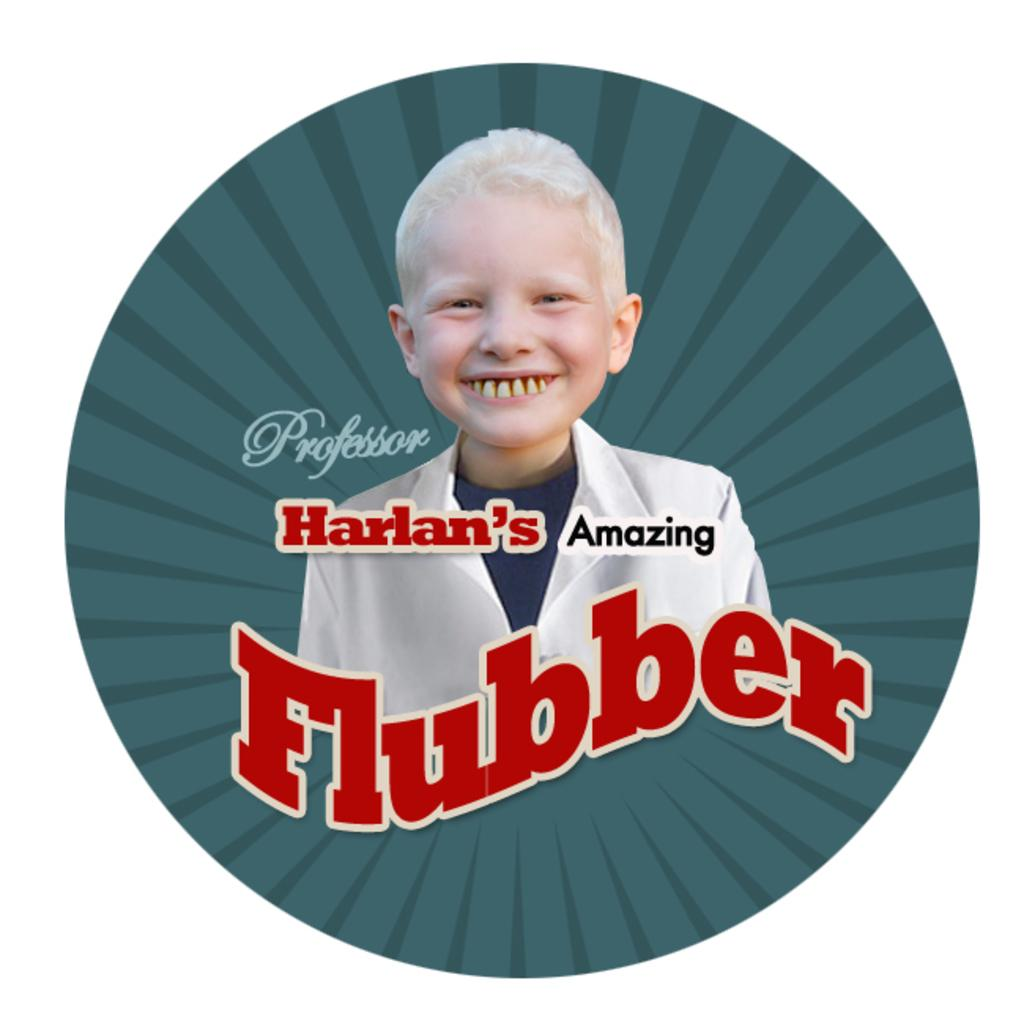<image>
Create a compact narrative representing the image presented. an ad with a little boy grinning amongst the words Flubber 